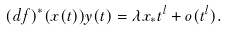Convert formula to latex. <formula><loc_0><loc_0><loc_500><loc_500>( d f ) ^ { * } ( x ( t ) ) y ( t ) = \lambda x _ { * } t ^ { l } + o ( t ^ { l } ) .</formula> 